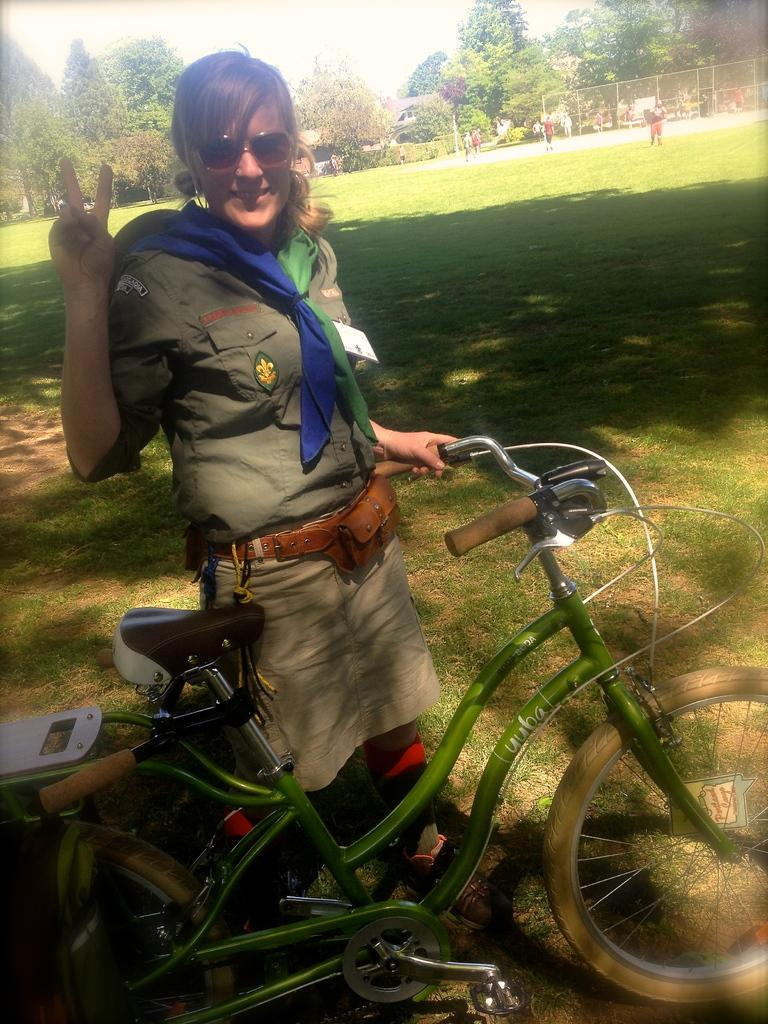Who is present in the image? There is a woman in the image. What is the woman holding in the image? The woman is holding a bicycle. What can be seen in the background of the image? There is grass and trees in the background of the image. What type of star can be seen in the woman's face in the image? There is no star present in the woman's face in the image. 